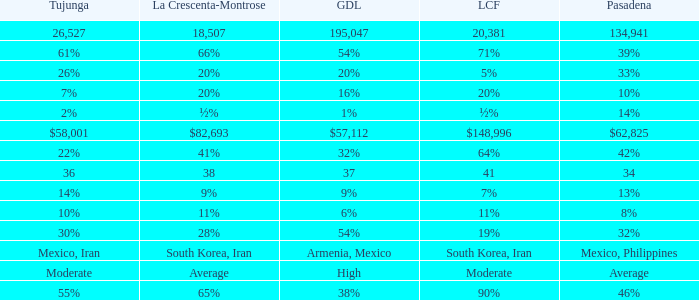Parse the table in full. {'header': ['Tujunga', 'La Crescenta-Montrose', 'GDL', 'LCF', 'Pasadena'], 'rows': [['26,527', '18,507', '195,047', '20,381', '134,941'], ['61%', '66%', '54%', '71%', '39%'], ['26%', '20%', '20%', '5%', '33%'], ['7%', '20%', '16%', '20%', '10%'], ['2%', '½%', '1%', '½%', '14%'], ['$58,001', '$82,693', '$57,112', '$148,996', '$62,825'], ['22%', '41%', '32%', '64%', '42%'], ['36', '38', '37', '41', '34'], ['14%', '9%', '9%', '7%', '13%'], ['10%', '11%', '6%', '11%', '8%'], ['30%', '28%', '54%', '19%', '32%'], ['Mexico, Iran', 'South Korea, Iran', 'Armenia, Mexico', 'South Korea, Iran', 'Mexico, Philippines'], ['Moderate', 'Average', 'High', 'Moderate', 'Average'], ['55%', '65%', '38%', '90%', '46%']]} What is the percentage of La Canada Flintridge when Tujunga is 7%? 20%. 